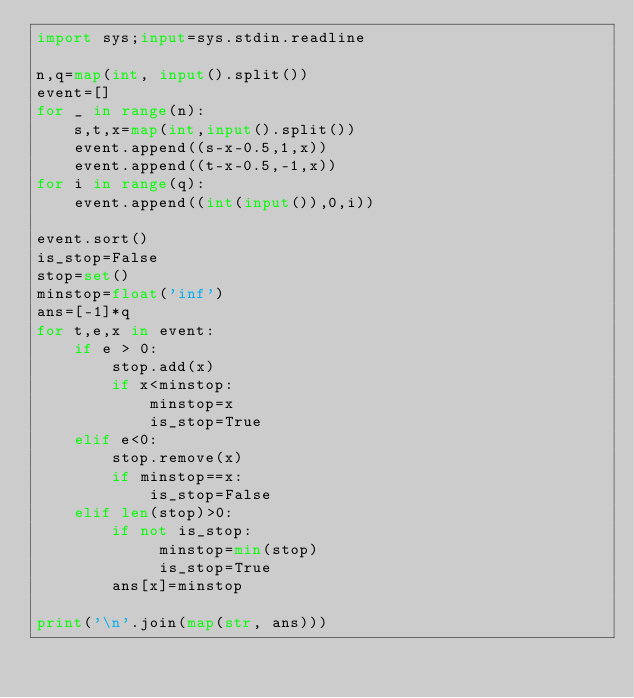Convert code to text. <code><loc_0><loc_0><loc_500><loc_500><_Python_>import sys;input=sys.stdin.readline

n,q=map(int, input().split())
event=[]
for _ in range(n):
    s,t,x=map(int,input().split())
    event.append((s-x-0.5,1,x))
    event.append((t-x-0.5,-1,x))
for i in range(q):
    event.append((int(input()),0,i))

event.sort()
is_stop=False
stop=set()
minstop=float('inf')
ans=[-1]*q
for t,e,x in event:
    if e > 0:
        stop.add(x)
        if x<minstop:
            minstop=x
            is_stop=True
    elif e<0:
        stop.remove(x)
        if minstop==x:
            is_stop=False
    elif len(stop)>0:
        if not is_stop:
             minstop=min(stop)
             is_stop=True
        ans[x]=minstop

print('\n'.join(map(str, ans)))</code> 